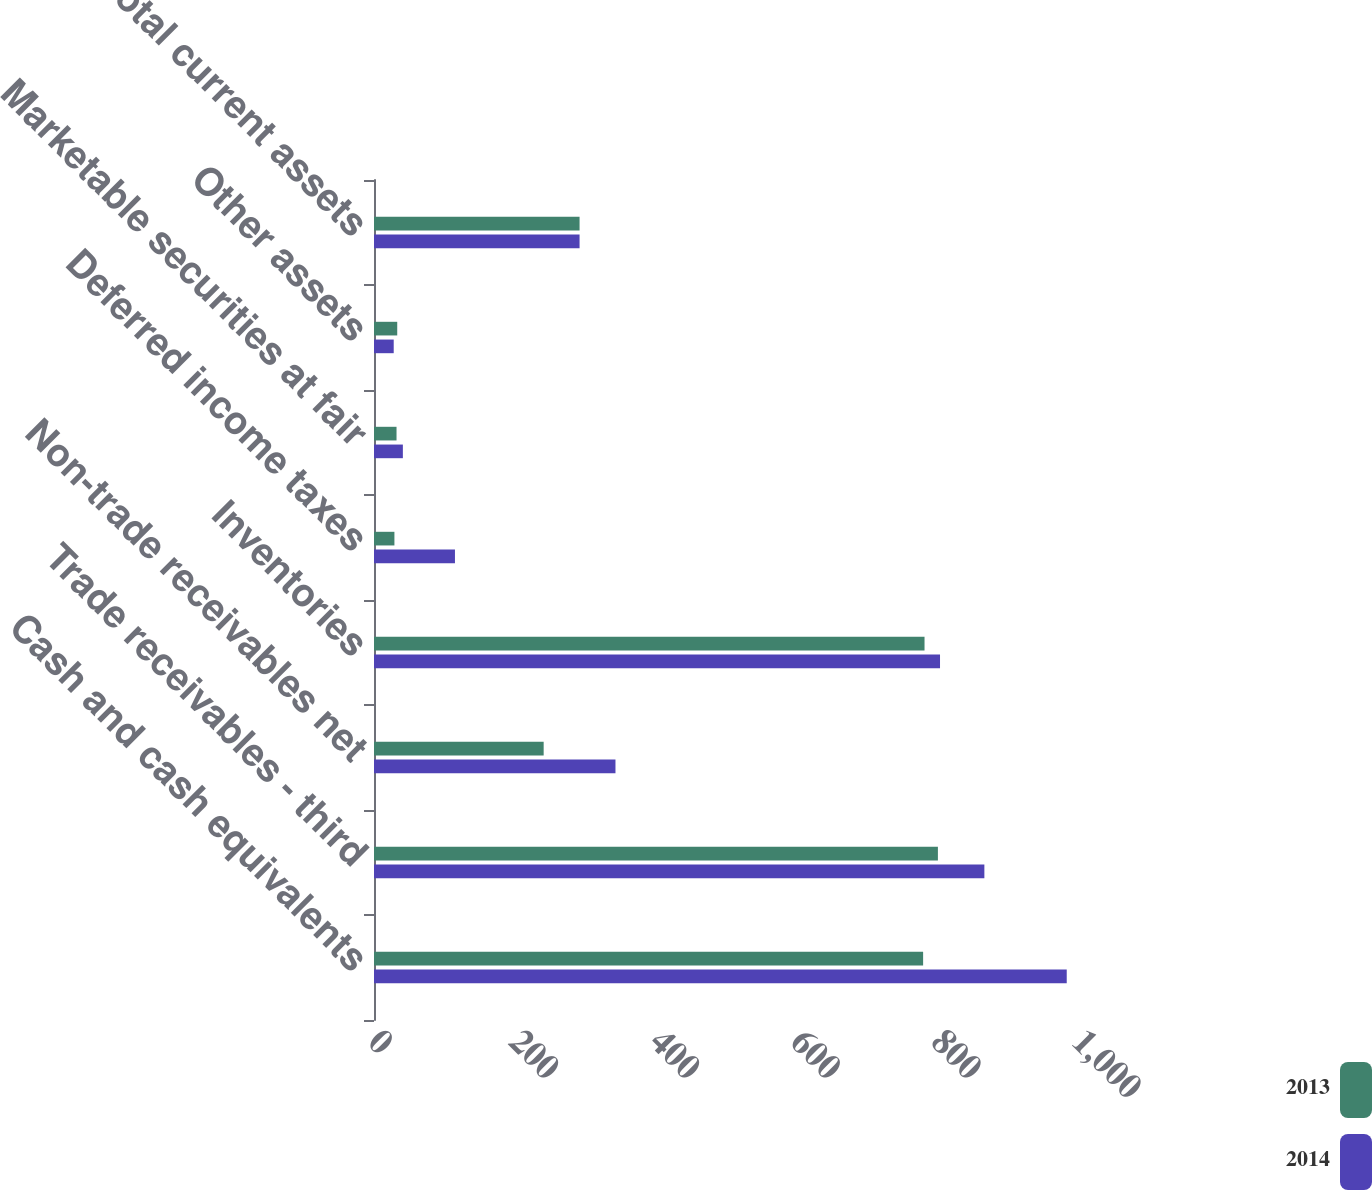Convert chart to OTSL. <chart><loc_0><loc_0><loc_500><loc_500><stacked_bar_chart><ecel><fcel>Cash and cash equivalents<fcel>Trade receivables - third<fcel>Non-trade receivables net<fcel>Inventories<fcel>Deferred income taxes<fcel>Marketable securities at fair<fcel>Other assets<fcel>Total current assets<nl><fcel>2013<fcel>780<fcel>801<fcel>241<fcel>782<fcel>29<fcel>32<fcel>33<fcel>292<nl><fcel>2014<fcel>984<fcel>867<fcel>343<fcel>804<fcel>115<fcel>41<fcel>28<fcel>292<nl></chart> 